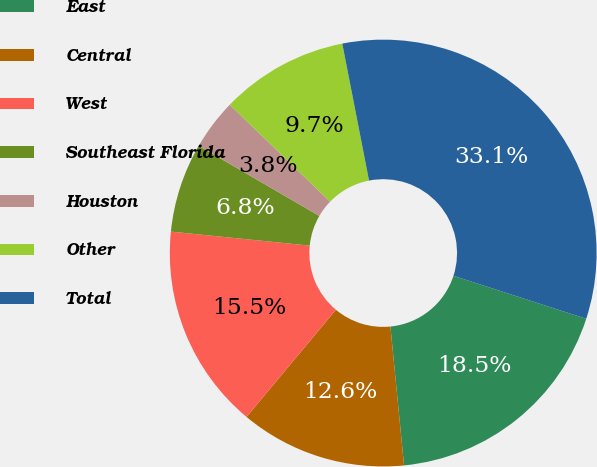<chart> <loc_0><loc_0><loc_500><loc_500><pie_chart><fcel>East<fcel>Central<fcel>West<fcel>Southeast Florida<fcel>Houston<fcel>Other<fcel>Total<nl><fcel>18.46%<fcel>12.62%<fcel>15.54%<fcel>6.78%<fcel>3.85%<fcel>9.7%<fcel>33.06%<nl></chart> 